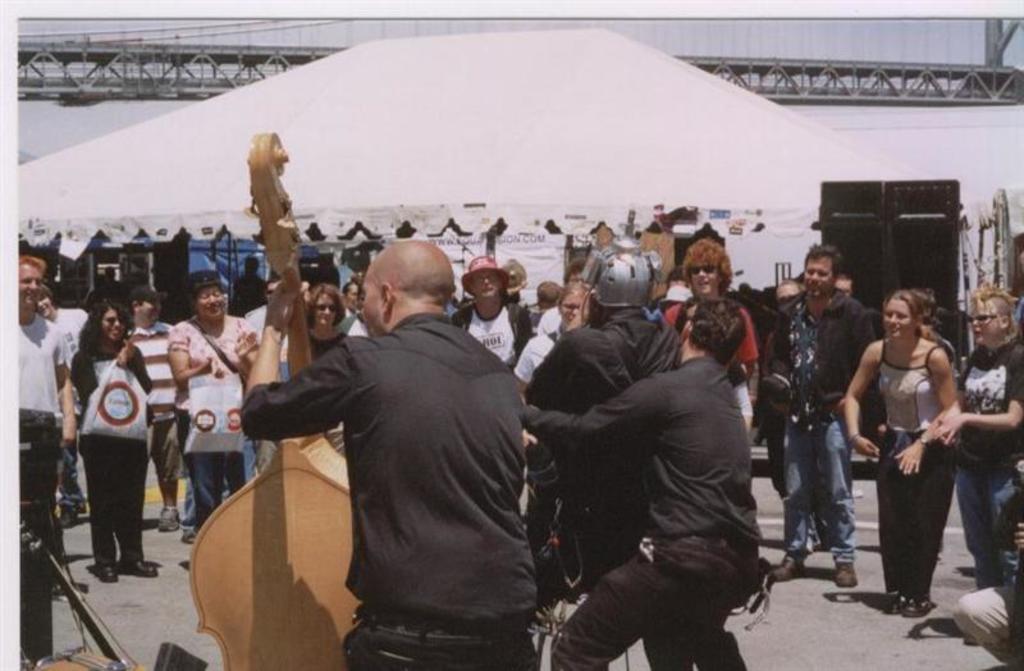Describe this image in one or two sentences. In the foreground of the image, we can see three men. One man is playing a musical instrument. In the background, we can see so many people, shelter and a black color object. We can see a musical instrument in the left bottom of the image. At the top of the image, we can see a metal object and the sky. 